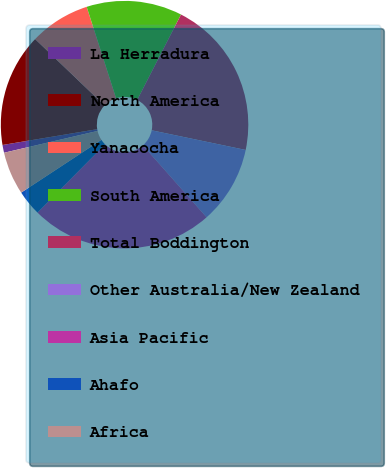Convert chart to OTSL. <chart><loc_0><loc_0><loc_500><loc_500><pie_chart><fcel>La Herradura<fcel>North America<fcel>Yanacocha<fcel>South America<fcel>Total Boddington<fcel>Other Australia/New Zealand<fcel>Asia Pacific<fcel>Ahafo<fcel>Africa<nl><fcel>1.02%<fcel>14.78%<fcel>7.9%<fcel>12.49%<fcel>20.74%<fcel>10.19%<fcel>23.95%<fcel>3.32%<fcel>5.61%<nl></chart> 